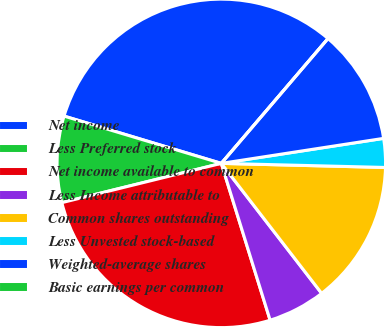<chart> <loc_0><loc_0><loc_500><loc_500><pie_chart><fcel>Net income<fcel>Less Preferred stock<fcel>Net income available to common<fcel>Less Income attributable to<fcel>Common shares outstanding<fcel>Less Unvested stock-based<fcel>Weighted-average shares<fcel>Basic earnings per common<nl><fcel>31.61%<fcel>8.49%<fcel>25.96%<fcel>5.66%<fcel>14.14%<fcel>2.83%<fcel>11.31%<fcel>0.0%<nl></chart> 